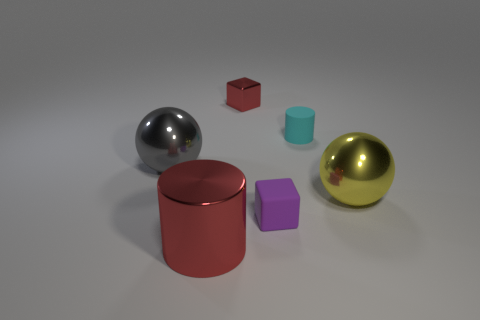How many tiny things are either red cubes or cyan rubber cylinders?
Offer a terse response. 2. What number of blue matte objects are there?
Your response must be concise. 0. What material is the cylinder that is behind the large red metal thing?
Your answer should be very brief. Rubber. There is a cyan cylinder; are there any metal things on the left side of it?
Provide a succinct answer. Yes. Do the yellow shiny sphere and the gray object have the same size?
Provide a short and direct response. Yes. What number of small cyan objects are the same material as the purple thing?
Offer a very short reply. 1. There is a red metallic thing to the left of the red metal object that is behind the red cylinder; what is its size?
Your answer should be compact. Large. What color is the metal object that is to the right of the red metal cylinder and left of the tiny cylinder?
Make the answer very short. Red. Do the big gray metal thing and the small red metallic object have the same shape?
Make the answer very short. No. What size is the other object that is the same color as the tiny shiny object?
Make the answer very short. Large. 